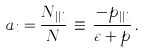<formula> <loc_0><loc_0><loc_500><loc_500>a _ { i } = \frac { N _ { | | i } } { N } \, \equiv \, \frac { - p _ { | | i } } { \varepsilon + p } \, .</formula> 